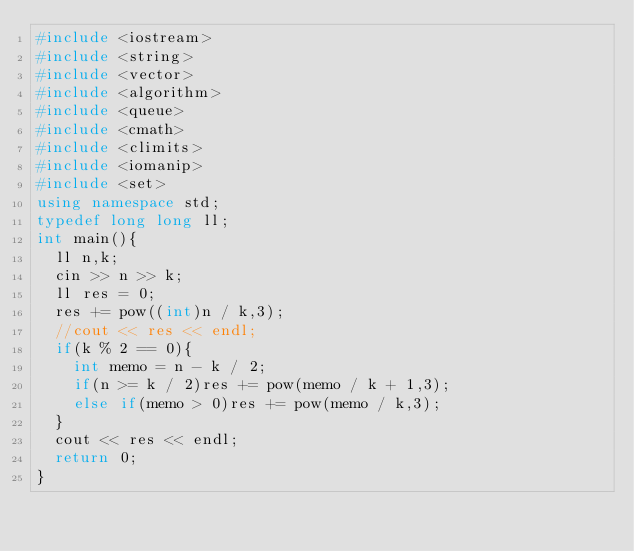<code> <loc_0><loc_0><loc_500><loc_500><_C++_>#include <iostream>
#include <string>
#include <vector>
#include <algorithm>
#include <queue>
#include <cmath>
#include <climits>
#include <iomanip>
#include <set>
using namespace std;
typedef long long ll;
int main(){
  ll n,k;
  cin >> n >> k;
  ll res = 0;
  res += pow((int)n / k,3);
  //cout << res << endl;
  if(k % 2 == 0){
    int memo = n - k / 2;
    if(n >= k / 2)res += pow(memo / k + 1,3);
    else if(memo > 0)res += pow(memo / k,3);
  }
  cout << res << endl;
  return 0;
}</code> 